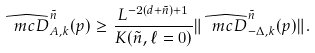Convert formula to latex. <formula><loc_0><loc_0><loc_500><loc_500>\widehat { \ m c { D } } _ { A , k } ^ { \tilde { n } } ( p ) \geq \frac { L ^ { - 2 ( d + \tilde { n } ) + 1 } } { K ( \tilde { n } , \ell = 0 ) } \| \widehat { \ m c { D } } _ { - \Delta , k } ^ { \tilde { n } } ( p ) \| .</formula> 